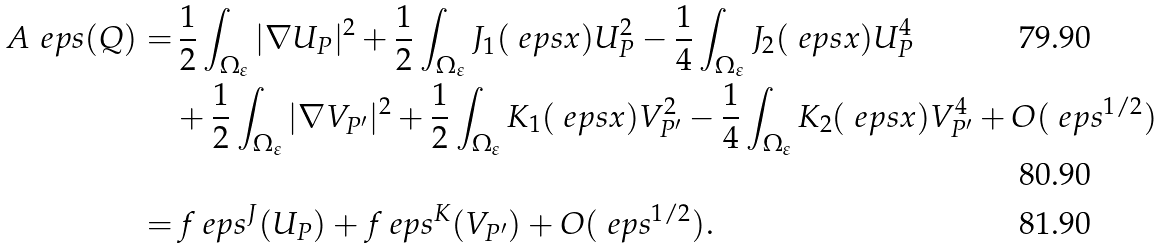<formula> <loc_0><loc_0><loc_500><loc_500>\ A _ { \ } e p s ( Q ) = & \, \frac { 1 } { 2 } \int _ { \Omega _ { \varepsilon } } | \nabla U _ { P } | ^ { 2 } + \frac { 1 } { 2 } \int _ { \Omega _ { \varepsilon } } J _ { 1 } ( \ e p s x ) U _ { P } ^ { 2 } - \frac { 1 } { 4 } \int _ { \Omega _ { \varepsilon } } J _ { 2 } ( \ e p s x ) U _ { P } ^ { 4 } \\ & + \frac { 1 } { 2 } \int _ { \Omega _ { \varepsilon } } | \nabla V _ { P ^ { \prime } } | ^ { 2 } + \frac { 1 } { 2 } \int _ { \Omega _ { \varepsilon } } K _ { 1 } ( \ e p s x ) V _ { P ^ { \prime } } ^ { 2 } - \frac { 1 } { 4 } \int _ { \Omega _ { \varepsilon } } K _ { 2 } ( \ e p s x ) V _ { P ^ { \prime } } ^ { 4 } + O ( \ e p s ^ { 1 / 2 } ) \\ = & \, f _ { \ } e p s ^ { J } ( U _ { P } ) + f _ { \ } e p s ^ { K } ( V _ { P ^ { \prime } } ) + O ( \ e p s ^ { 1 / 2 } ) .</formula> 